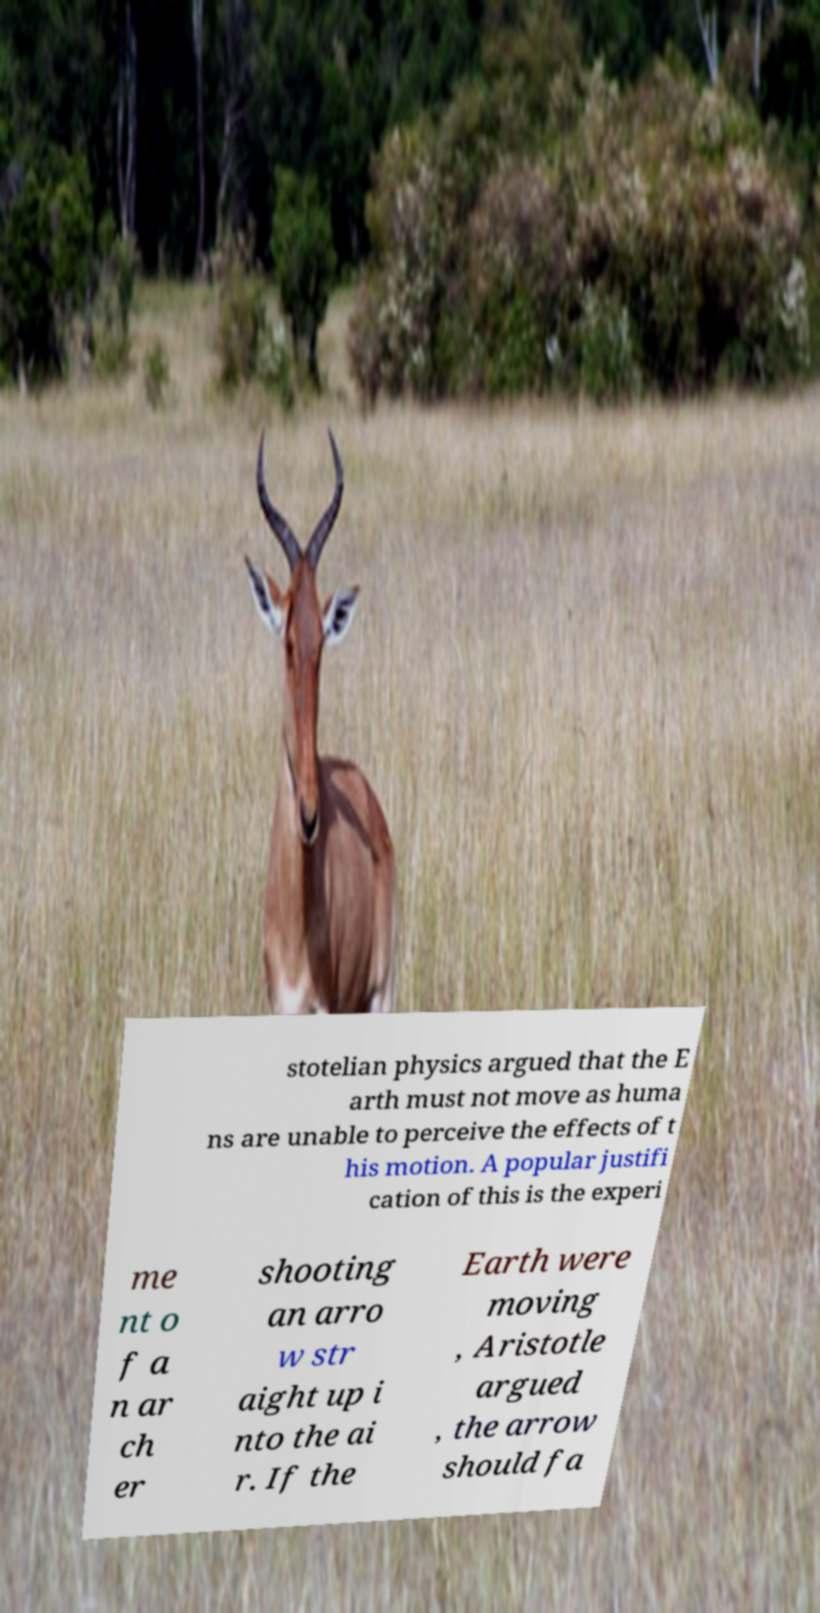Please identify and transcribe the text found in this image. stotelian physics argued that the E arth must not move as huma ns are unable to perceive the effects of t his motion. A popular justifi cation of this is the experi me nt o f a n ar ch er shooting an arro w str aight up i nto the ai r. If the Earth were moving , Aristotle argued , the arrow should fa 